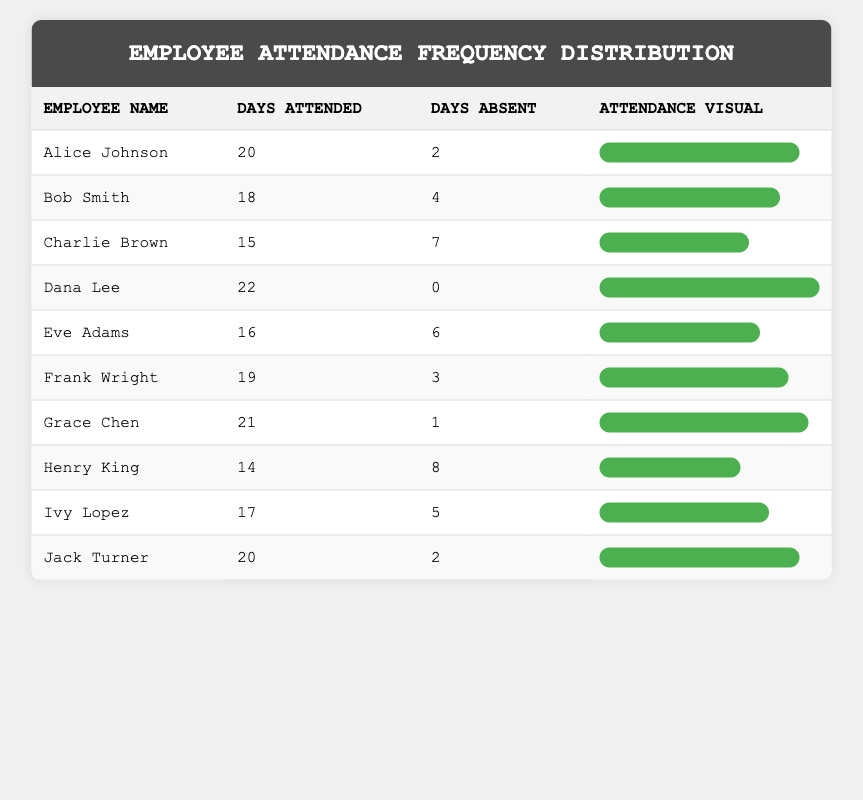What is the maximum number of days attended by any employee? By inspecting the 'Days Attended' column, I see the highest value is 22, associated with Dana Lee.
Answer: 22 How many employees attended more than 20 days? Scanning the table reveals that only Dana Lee and Grace Chen attended more than 20 days. So, there are 2 employees.
Answer: 2 Which employee has the highest absenteeism? Looking at the 'Days Absent' column, Henry King has the most absences listed at 8 days.
Answer: Henry King What is the average number of days attended by all employees? I sum the days attended: (20 + 18 + 15 + 22 + 16 + 19 + 21 + 14 + 17 + 20) = 202. There are 10 employees, so the average is 202/10 = 20.2.
Answer: 20.2 Is it true that the majority of employees attended 18 days or more? To check, I count those who attended 18 days or more: Alice Johnson, Bob Smith, Dana Lee, Frank Wright, Grace Chen, Jack Turner (6 out of 10). Since 6 is greater than half of 10, the statement is true.
Answer: Yes What is the total absenteeism of the team? To find this, I add up all the days absent: (2 + 4 + 7 + 0 + 6 + 3 + 1 + 8 + 5 + 2) = 38.
Answer: 38 How many employees attended between 15 to 19 days? In the given range, Bob Smith, Charlie Brown, Frank Wright, and Ivy Lopez fit the criteria. This adds up to 4 employees.
Answer: 4 What is the difference in attendance between the highest and lowest attended days? The highest attended days is 22 (Dana Lee) and the lowest is 14 (Henry King). The difference is 22 - 14 = 8.
Answer: 8 Who attended exactly 20 days? Observing the table, both Alice Johnson and Jack Turner attended exactly 20 days.
Answer: Alice Johnson, Jack Turner 